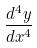Convert formula to latex. <formula><loc_0><loc_0><loc_500><loc_500>\frac { d ^ { 4 } y } { d x ^ { 4 } }</formula> 